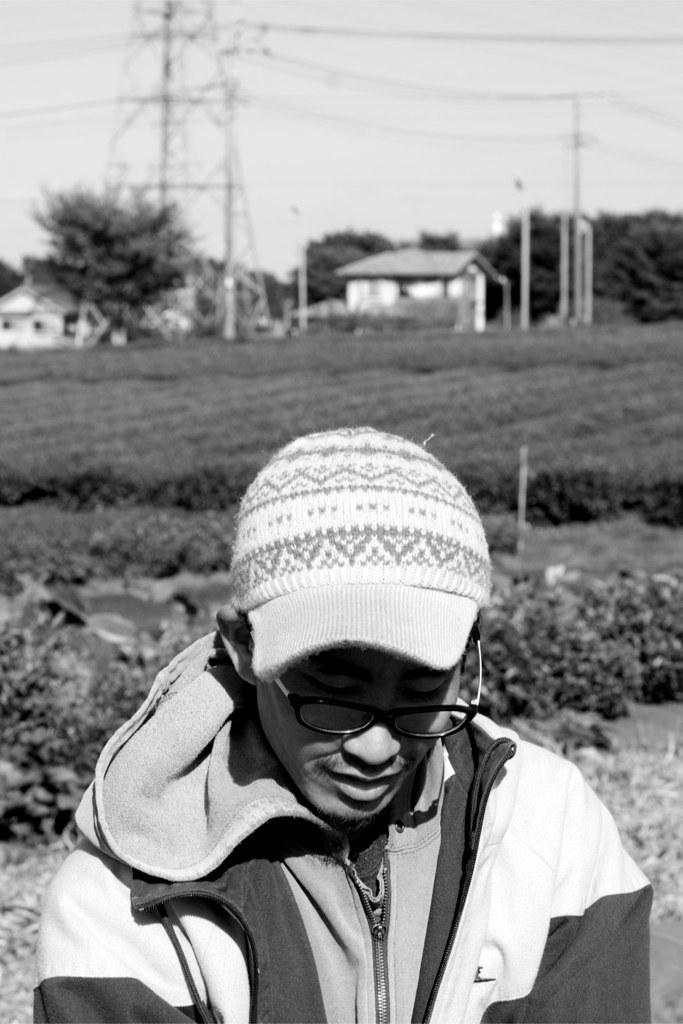What is the main subject of the image? There is a person standing in the image. What is the person wearing on their head? The person is wearing a cap. What type of clothing is the person wearing on their upper body? The person is wearing a jacket. What can be seen in the background of the image? There are houses, trees, electric poles, and the sky visible in the background of the image. What is the color scheme of the image? The image is in black and white. What type of owl can be seen perched on the person's shoulder in the image? There is no owl present in the image; the person is standing alone. What is the person's opinion on the current political situation in the image? The image does not provide any information about the person's opinion on the current political situation. 